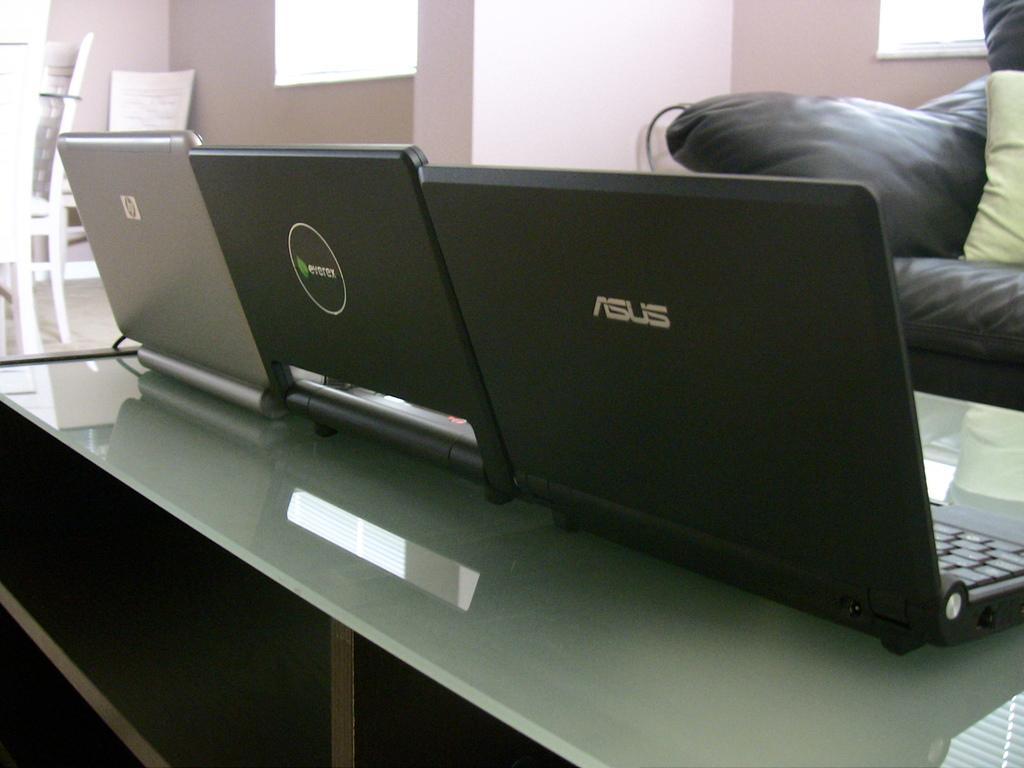In one or two sentences, can you explain what this image depicts? The picture is inside a room. There is a table in the middle. On the table there are laptops. On the right top corner there is a sofa. On the left top corner there is table and chairs. in the background there is wall and windows. 